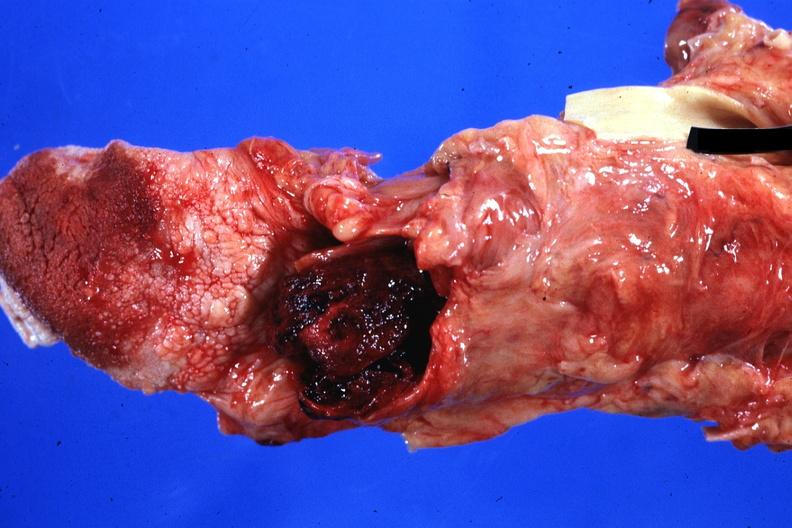what is blood clot standing?
Answer the question using a single word or phrase. Case of myeloproliferative disorder with terminal acute transformation and bleeding disorder 